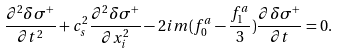<formula> <loc_0><loc_0><loc_500><loc_500>\frac { \partial ^ { 2 } \delta \sigma ^ { + } } { \partial t ^ { 2 } } + c _ { s } ^ { 2 } \frac { \partial ^ { 2 } \delta \sigma ^ { + } } { \partial x _ { i } ^ { 2 } } - 2 i m ( f _ { 0 } ^ { a } - \frac { f _ { 1 } ^ { a } } { 3 } ) \frac { \partial \delta \sigma ^ { + } } { \partial t } = 0 .</formula> 